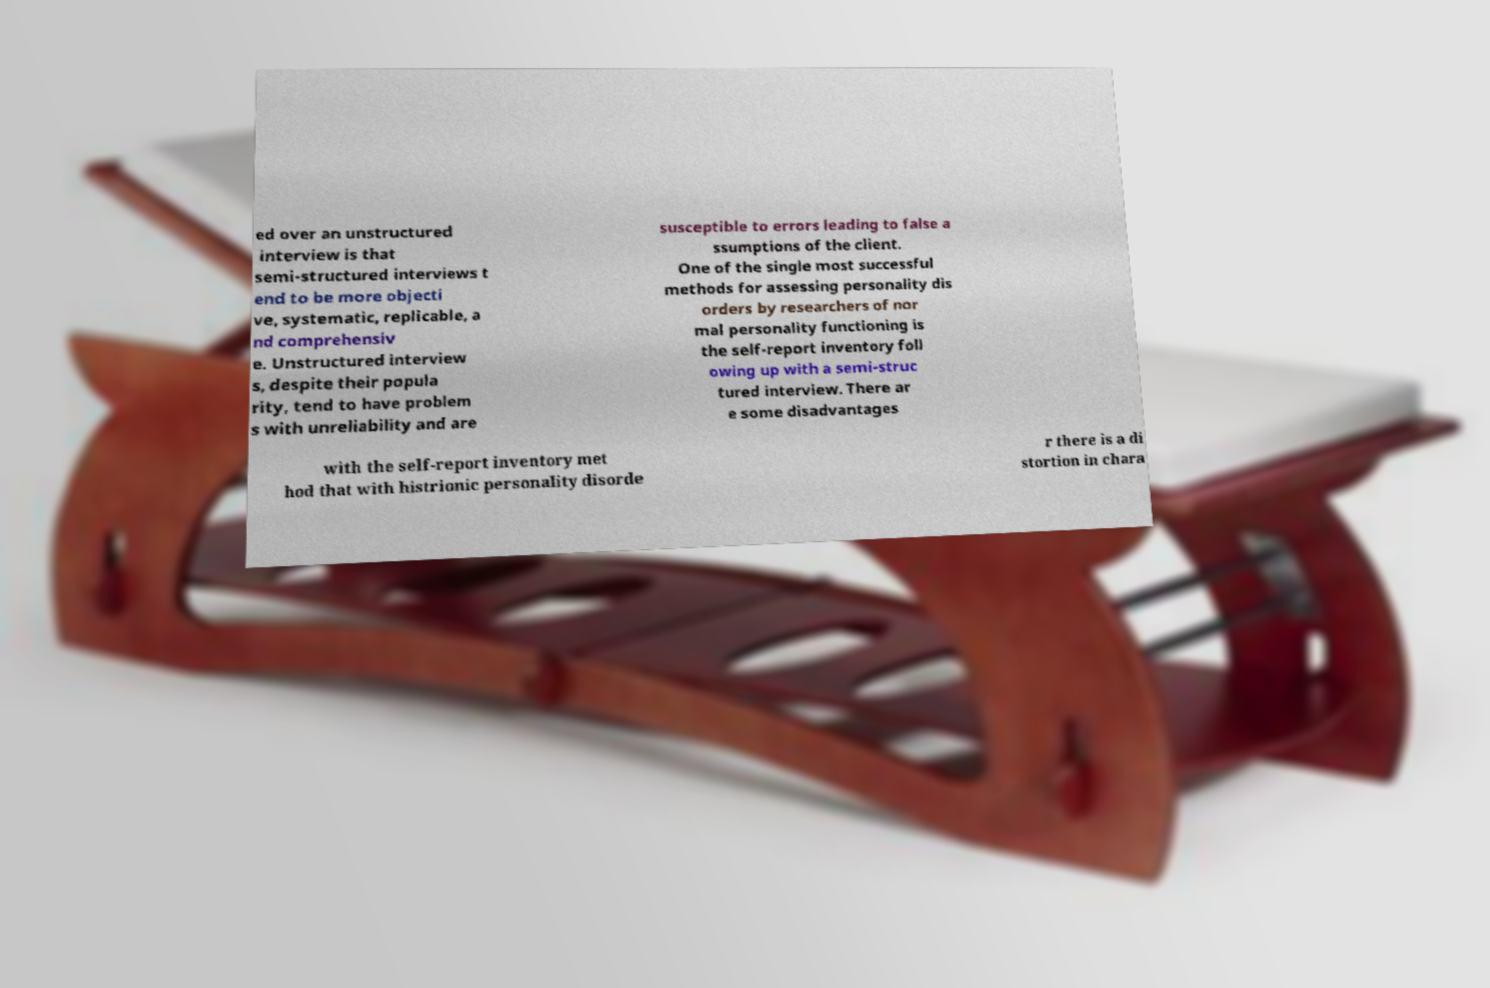Could you extract and type out the text from this image? ed over an unstructured interview is that semi-structured interviews t end to be more objecti ve, systematic, replicable, a nd comprehensiv e. Unstructured interview s, despite their popula rity, tend to have problem s with unreliability and are susceptible to errors leading to false a ssumptions of the client. One of the single most successful methods for assessing personality dis orders by researchers of nor mal personality functioning is the self-report inventory foll owing up with a semi-struc tured interview. There ar e some disadvantages with the self-report inventory met hod that with histrionic personality disorde r there is a di stortion in chara 